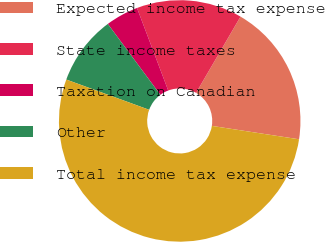Convert chart to OTSL. <chart><loc_0><loc_0><loc_500><loc_500><pie_chart><fcel>Expected income tax expense<fcel>State income taxes<fcel>Taxation on Canadian<fcel>Other<fcel>Total income tax expense<nl><fcel>19.03%<fcel>14.15%<fcel>4.4%<fcel>9.28%<fcel>53.14%<nl></chart> 